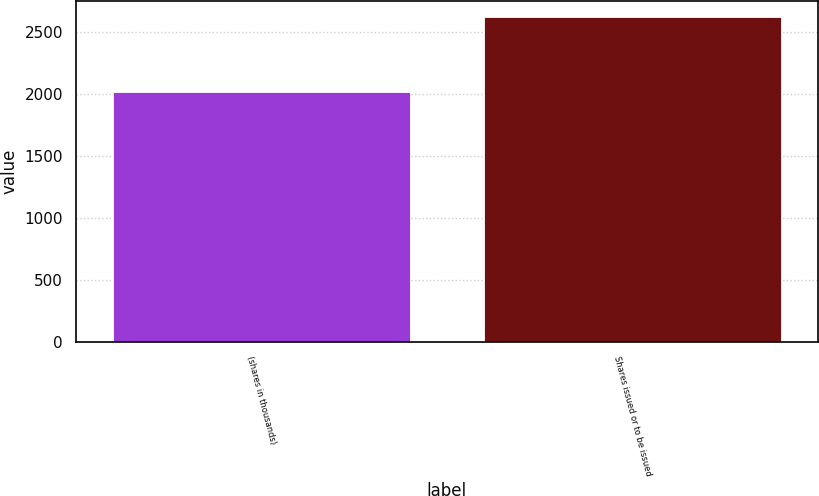<chart> <loc_0><loc_0><loc_500><loc_500><bar_chart><fcel>(shares in thousands)<fcel>Shares issued or to be issued<nl><fcel>2014<fcel>2618<nl></chart> 